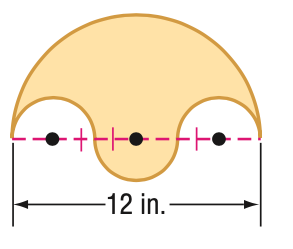Question: Find the area of the shaded region.
Choices:
A. 12.6
B. 50.3
C. 100.5
D. 402.1
Answer with the letter. Answer: B 